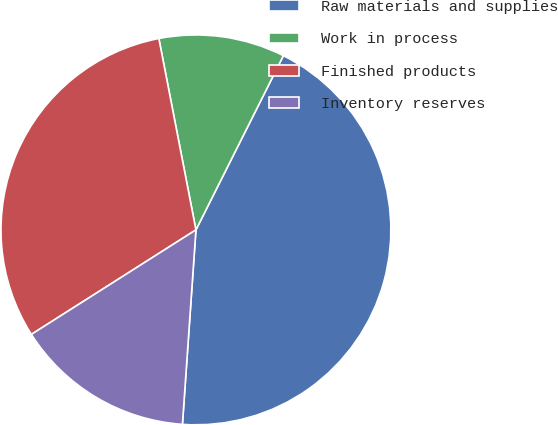<chart> <loc_0><loc_0><loc_500><loc_500><pie_chart><fcel>Raw materials and supplies<fcel>Work in process<fcel>Finished products<fcel>Inventory reserves<nl><fcel>43.7%<fcel>10.45%<fcel>30.96%<fcel>14.89%<nl></chart> 